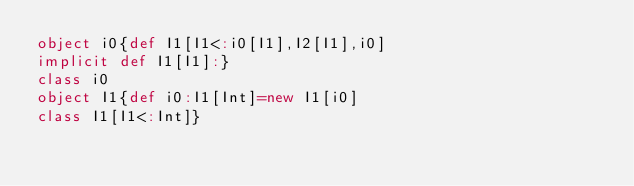Convert code to text. <code><loc_0><loc_0><loc_500><loc_500><_Scala_>object i0{def I1[I1<:i0[I1],I2[I1],i0]
implicit def I1[I1]:}
class i0
object I1{def i0:I1[Int]=new I1[i0]
class I1[I1<:Int]}
</code> 